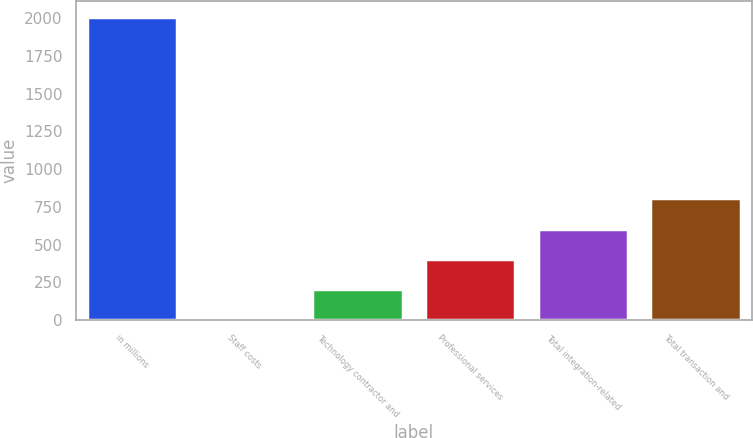<chart> <loc_0><loc_0><loc_500><loc_500><bar_chart><fcel>in millions<fcel>Staff costs<fcel>Technology contractor and<fcel>Professional services<fcel>Total integration-related<fcel>Total transaction and<nl><fcel>2011<fcel>2.8<fcel>203.62<fcel>404.44<fcel>605.26<fcel>806.08<nl></chart> 